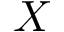<formula> <loc_0><loc_0><loc_500><loc_500>X</formula> 